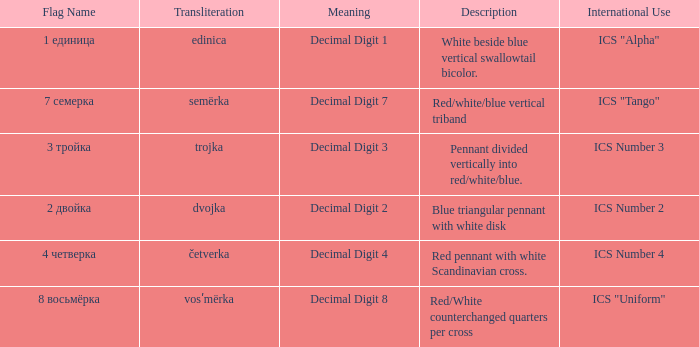What are the meanings of the flag whose name transliterates to semërka? Decimal Digit 7. 